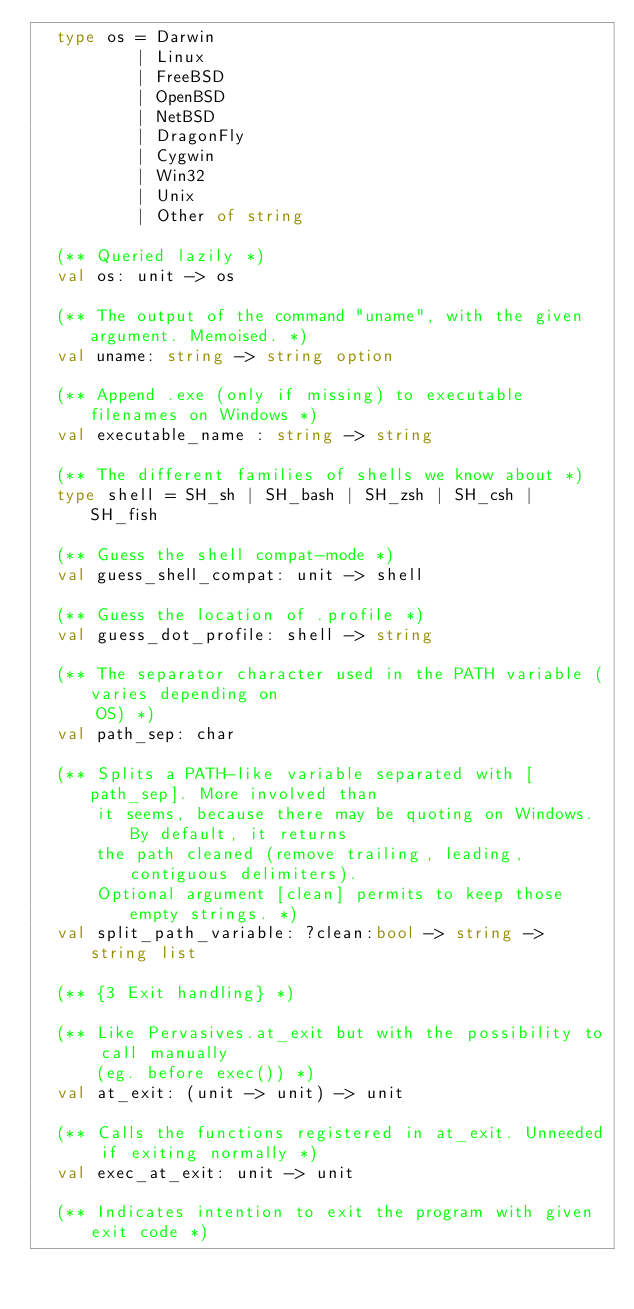<code> <loc_0><loc_0><loc_500><loc_500><_OCaml_>  type os = Darwin
          | Linux
          | FreeBSD
          | OpenBSD
          | NetBSD
          | DragonFly
          | Cygwin
          | Win32
          | Unix
          | Other of string

  (** Queried lazily *)
  val os: unit -> os

  (** The output of the command "uname", with the given argument. Memoised. *)
  val uname: string -> string option

  (** Append .exe (only if missing) to executable filenames on Windows *)
  val executable_name : string -> string

  (** The different families of shells we know about *)
  type shell = SH_sh | SH_bash | SH_zsh | SH_csh | SH_fish

  (** Guess the shell compat-mode *)
  val guess_shell_compat: unit -> shell

  (** Guess the location of .profile *)
  val guess_dot_profile: shell -> string

  (** The separator character used in the PATH variable (varies depending on
      OS) *)
  val path_sep: char

  (** Splits a PATH-like variable separated with [path_sep]. More involved than
      it seems, because there may be quoting on Windows. By default, it returns
      the path cleaned (remove trailing, leading, contiguous delimiters).
      Optional argument [clean] permits to keep those empty strings. *)
  val split_path_variable: ?clean:bool -> string -> string list

  (** {3 Exit handling} *)

  (** Like Pervasives.at_exit but with the possibility to call manually
      (eg. before exec()) *)
  val at_exit: (unit -> unit) -> unit

  (** Calls the functions registered in at_exit. Unneeded if exiting normally *)
  val exec_at_exit: unit -> unit

  (** Indicates intention to exit the program with given exit code *)</code> 